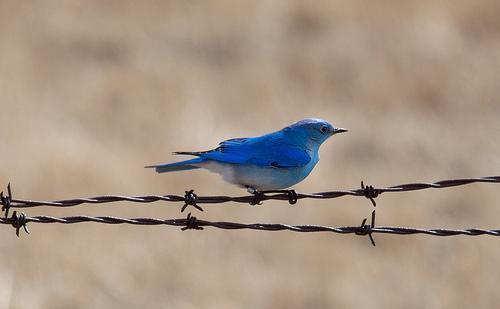How many birds are in the picture?
Give a very brief answer. 1. 